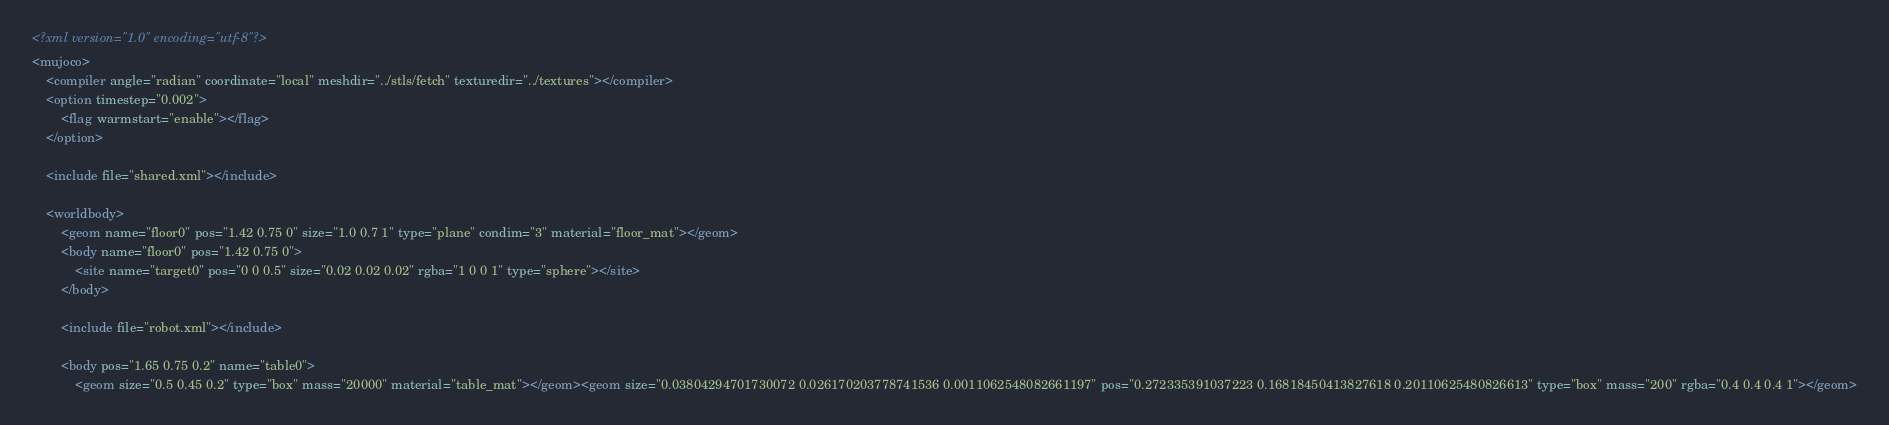<code> <loc_0><loc_0><loc_500><loc_500><_XML_><?xml version="1.0" encoding="utf-8"?>
<mujoco>
    <compiler angle="radian" coordinate="local" meshdir="../stls/fetch" texturedir="../textures"></compiler>
    <option timestep="0.002">
        <flag warmstart="enable"></flag>
    </option>

    <include file="shared.xml"></include>
    
    <worldbody>
        <geom name="floor0" pos="1.42 0.75 0" size="1.0 0.7 1" type="plane" condim="3" material="floor_mat"></geom>
        <body name="floor0" pos="1.42 0.75 0">
            <site name="target0" pos="0 0 0.5" size="0.02 0.02 0.02" rgba="1 0 0 1" type="sphere"></site>
        </body>

        <include file="robot.xml"></include>
        
        <body pos="1.65 0.75 0.2" name="table0">
            <geom size="0.5 0.45 0.2" type="box" mass="20000" material="table_mat"></geom><geom size="0.03804294701730072 0.026170203778741536 0.0011062548082661197" pos="0.272335391037223 0.16818450413827618 0.20110625480826613" type="box" mass="200" rgba="0.4 0.4 0.4 1"></geom></code> 